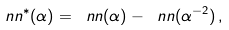<formula> <loc_0><loc_0><loc_500><loc_500>\ n n ^ { * } ( \alpha ) = \ n n ( \alpha ) - \ n n ( \alpha ^ { - 2 } ) \, ,</formula> 